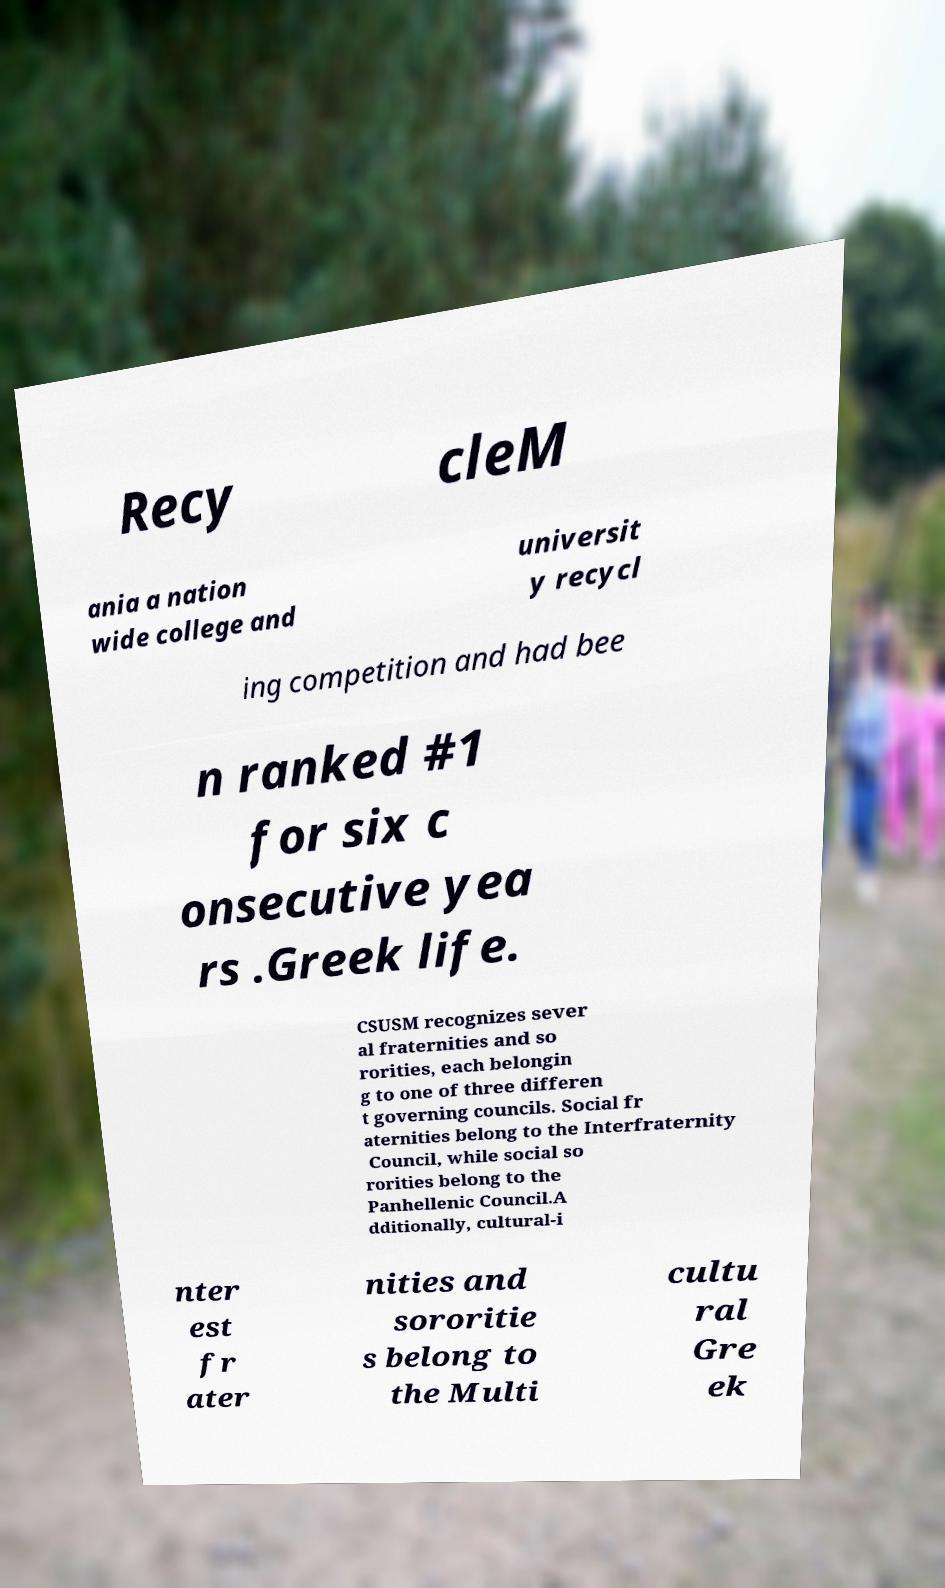For documentation purposes, I need the text within this image transcribed. Could you provide that? Recy cleM ania a nation wide college and universit y recycl ing competition and had bee n ranked #1 for six c onsecutive yea rs .Greek life. CSUSM recognizes sever al fraternities and so rorities, each belongin g to one of three differen t governing councils. Social fr aternities belong to the Interfraternity Council, while social so rorities belong to the Panhellenic Council.A dditionally, cultural-i nter est fr ater nities and sororitie s belong to the Multi cultu ral Gre ek 